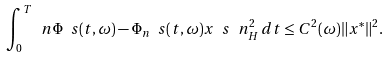<formula> <loc_0><loc_0><loc_500><loc_500>\int _ { 0 } ^ { T } \ n \Phi \ s ( t , \omega ) - \Phi _ { n } \ s ( t , \omega ) x \ s \ n _ { H } ^ { 2 } \, d t \leq C ^ { 2 } ( \omega ) \| x ^ { * } \| ^ { 2 } .</formula> 